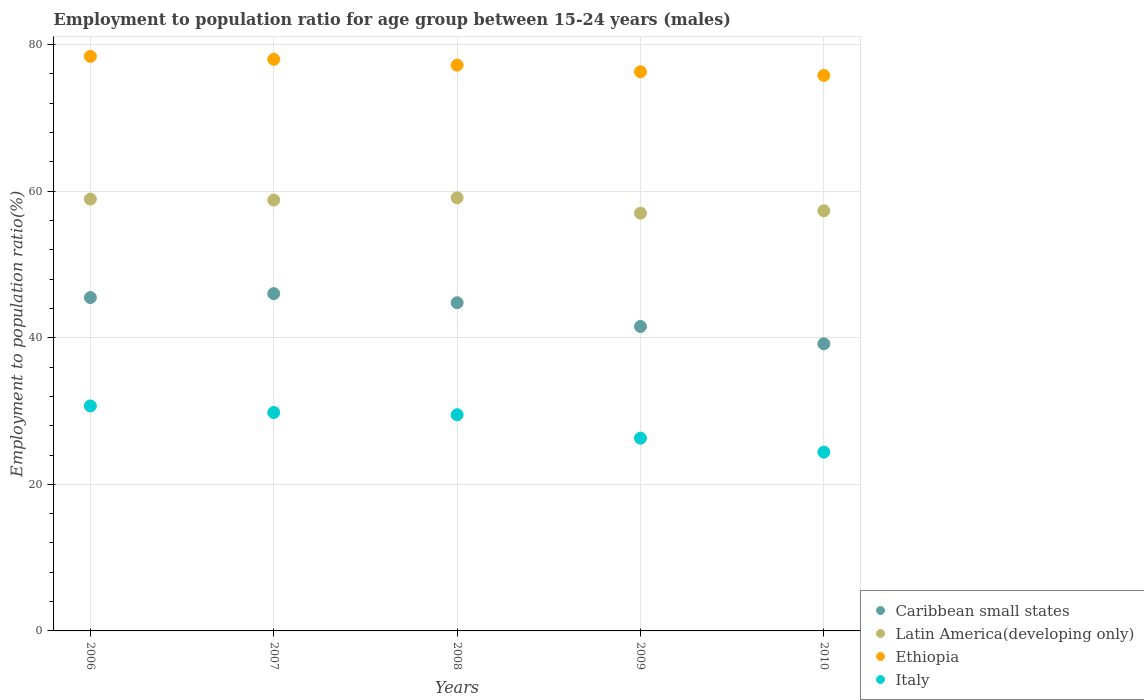How many different coloured dotlines are there?
Offer a very short reply. 4. Is the number of dotlines equal to the number of legend labels?
Make the answer very short. Yes. What is the employment to population ratio in Latin America(developing only) in 2009?
Keep it short and to the point. 57. Across all years, what is the maximum employment to population ratio in Caribbean small states?
Provide a succinct answer. 46.02. Across all years, what is the minimum employment to population ratio in Ethiopia?
Make the answer very short. 75.8. What is the total employment to population ratio in Italy in the graph?
Give a very brief answer. 140.7. What is the difference between the employment to population ratio in Ethiopia in 2007 and that in 2009?
Your answer should be very brief. 1.7. What is the difference between the employment to population ratio in Caribbean small states in 2006 and the employment to population ratio in Latin America(developing only) in 2007?
Make the answer very short. -13.3. What is the average employment to population ratio in Ethiopia per year?
Provide a short and direct response. 77.14. In the year 2008, what is the difference between the employment to population ratio in Latin America(developing only) and employment to population ratio in Caribbean small states?
Keep it short and to the point. 14.31. In how many years, is the employment to population ratio in Italy greater than 40 %?
Give a very brief answer. 0. What is the ratio of the employment to population ratio in Latin America(developing only) in 2007 to that in 2009?
Offer a very short reply. 1.03. Is the employment to population ratio in Italy in 2008 less than that in 2010?
Ensure brevity in your answer.  No. Is the difference between the employment to population ratio in Latin America(developing only) in 2007 and 2010 greater than the difference between the employment to population ratio in Caribbean small states in 2007 and 2010?
Offer a very short reply. No. What is the difference between the highest and the second highest employment to population ratio in Latin America(developing only)?
Offer a terse response. 0.18. What is the difference between the highest and the lowest employment to population ratio in Italy?
Provide a succinct answer. 6.3. Is it the case that in every year, the sum of the employment to population ratio in Latin America(developing only) and employment to population ratio in Caribbean small states  is greater than the sum of employment to population ratio in Ethiopia and employment to population ratio in Italy?
Give a very brief answer. Yes. Is the employment to population ratio in Ethiopia strictly greater than the employment to population ratio in Caribbean small states over the years?
Offer a terse response. Yes. Is the employment to population ratio in Ethiopia strictly less than the employment to population ratio in Latin America(developing only) over the years?
Ensure brevity in your answer.  No. How many dotlines are there?
Your response must be concise. 4. Does the graph contain grids?
Keep it short and to the point. Yes. How many legend labels are there?
Give a very brief answer. 4. What is the title of the graph?
Provide a succinct answer. Employment to population ratio for age group between 15-24 years (males). Does "Costa Rica" appear as one of the legend labels in the graph?
Make the answer very short. No. What is the Employment to population ratio(%) of Caribbean small states in 2006?
Provide a succinct answer. 45.49. What is the Employment to population ratio(%) of Latin America(developing only) in 2006?
Provide a short and direct response. 58.92. What is the Employment to population ratio(%) of Ethiopia in 2006?
Your response must be concise. 78.4. What is the Employment to population ratio(%) of Italy in 2006?
Your response must be concise. 30.7. What is the Employment to population ratio(%) of Caribbean small states in 2007?
Your answer should be compact. 46.02. What is the Employment to population ratio(%) of Latin America(developing only) in 2007?
Offer a very short reply. 58.79. What is the Employment to population ratio(%) of Ethiopia in 2007?
Provide a short and direct response. 78. What is the Employment to population ratio(%) of Italy in 2007?
Give a very brief answer. 29.8. What is the Employment to population ratio(%) of Caribbean small states in 2008?
Offer a terse response. 44.79. What is the Employment to population ratio(%) in Latin America(developing only) in 2008?
Your answer should be compact. 59.1. What is the Employment to population ratio(%) of Ethiopia in 2008?
Keep it short and to the point. 77.2. What is the Employment to population ratio(%) in Italy in 2008?
Provide a short and direct response. 29.5. What is the Employment to population ratio(%) in Caribbean small states in 2009?
Provide a succinct answer. 41.54. What is the Employment to population ratio(%) in Latin America(developing only) in 2009?
Make the answer very short. 57. What is the Employment to population ratio(%) of Ethiopia in 2009?
Offer a very short reply. 76.3. What is the Employment to population ratio(%) of Italy in 2009?
Your answer should be compact. 26.3. What is the Employment to population ratio(%) of Caribbean small states in 2010?
Offer a very short reply. 39.18. What is the Employment to population ratio(%) of Latin America(developing only) in 2010?
Make the answer very short. 57.33. What is the Employment to population ratio(%) in Ethiopia in 2010?
Offer a terse response. 75.8. What is the Employment to population ratio(%) in Italy in 2010?
Offer a very short reply. 24.4. Across all years, what is the maximum Employment to population ratio(%) in Caribbean small states?
Offer a very short reply. 46.02. Across all years, what is the maximum Employment to population ratio(%) in Latin America(developing only)?
Your answer should be very brief. 59.1. Across all years, what is the maximum Employment to population ratio(%) in Ethiopia?
Your response must be concise. 78.4. Across all years, what is the maximum Employment to population ratio(%) of Italy?
Ensure brevity in your answer.  30.7. Across all years, what is the minimum Employment to population ratio(%) in Caribbean small states?
Ensure brevity in your answer.  39.18. Across all years, what is the minimum Employment to population ratio(%) of Latin America(developing only)?
Provide a succinct answer. 57. Across all years, what is the minimum Employment to population ratio(%) of Ethiopia?
Your answer should be compact. 75.8. Across all years, what is the minimum Employment to population ratio(%) in Italy?
Keep it short and to the point. 24.4. What is the total Employment to population ratio(%) of Caribbean small states in the graph?
Your response must be concise. 217.02. What is the total Employment to population ratio(%) in Latin America(developing only) in the graph?
Provide a succinct answer. 291.14. What is the total Employment to population ratio(%) of Ethiopia in the graph?
Keep it short and to the point. 385.7. What is the total Employment to population ratio(%) in Italy in the graph?
Keep it short and to the point. 140.7. What is the difference between the Employment to population ratio(%) in Caribbean small states in 2006 and that in 2007?
Keep it short and to the point. -0.53. What is the difference between the Employment to population ratio(%) in Latin America(developing only) in 2006 and that in 2007?
Your answer should be compact. 0.13. What is the difference between the Employment to population ratio(%) in Ethiopia in 2006 and that in 2007?
Ensure brevity in your answer.  0.4. What is the difference between the Employment to population ratio(%) in Italy in 2006 and that in 2007?
Provide a succinct answer. 0.9. What is the difference between the Employment to population ratio(%) in Caribbean small states in 2006 and that in 2008?
Offer a terse response. 0.7. What is the difference between the Employment to population ratio(%) in Latin America(developing only) in 2006 and that in 2008?
Offer a very short reply. -0.18. What is the difference between the Employment to population ratio(%) of Caribbean small states in 2006 and that in 2009?
Provide a short and direct response. 3.95. What is the difference between the Employment to population ratio(%) of Latin America(developing only) in 2006 and that in 2009?
Offer a terse response. 1.92. What is the difference between the Employment to population ratio(%) of Ethiopia in 2006 and that in 2009?
Offer a very short reply. 2.1. What is the difference between the Employment to population ratio(%) in Caribbean small states in 2006 and that in 2010?
Provide a short and direct response. 6.31. What is the difference between the Employment to population ratio(%) of Latin America(developing only) in 2006 and that in 2010?
Your answer should be compact. 1.59. What is the difference between the Employment to population ratio(%) in Caribbean small states in 2007 and that in 2008?
Provide a short and direct response. 1.24. What is the difference between the Employment to population ratio(%) of Latin America(developing only) in 2007 and that in 2008?
Your answer should be compact. -0.31. What is the difference between the Employment to population ratio(%) of Ethiopia in 2007 and that in 2008?
Give a very brief answer. 0.8. What is the difference between the Employment to population ratio(%) of Caribbean small states in 2007 and that in 2009?
Offer a very short reply. 4.48. What is the difference between the Employment to population ratio(%) in Latin America(developing only) in 2007 and that in 2009?
Make the answer very short. 1.79. What is the difference between the Employment to population ratio(%) in Ethiopia in 2007 and that in 2009?
Make the answer very short. 1.7. What is the difference between the Employment to population ratio(%) of Caribbean small states in 2007 and that in 2010?
Provide a short and direct response. 6.84. What is the difference between the Employment to population ratio(%) in Latin America(developing only) in 2007 and that in 2010?
Your answer should be compact. 1.46. What is the difference between the Employment to population ratio(%) of Caribbean small states in 2008 and that in 2009?
Make the answer very short. 3.24. What is the difference between the Employment to population ratio(%) of Latin America(developing only) in 2008 and that in 2009?
Give a very brief answer. 2.1. What is the difference between the Employment to population ratio(%) of Ethiopia in 2008 and that in 2009?
Provide a short and direct response. 0.9. What is the difference between the Employment to population ratio(%) in Italy in 2008 and that in 2009?
Give a very brief answer. 3.2. What is the difference between the Employment to population ratio(%) of Caribbean small states in 2008 and that in 2010?
Offer a terse response. 5.6. What is the difference between the Employment to population ratio(%) in Latin America(developing only) in 2008 and that in 2010?
Your answer should be very brief. 1.77. What is the difference between the Employment to population ratio(%) in Ethiopia in 2008 and that in 2010?
Your answer should be very brief. 1.4. What is the difference between the Employment to population ratio(%) of Caribbean small states in 2009 and that in 2010?
Provide a short and direct response. 2.36. What is the difference between the Employment to population ratio(%) of Latin America(developing only) in 2009 and that in 2010?
Your response must be concise. -0.33. What is the difference between the Employment to population ratio(%) in Italy in 2009 and that in 2010?
Keep it short and to the point. 1.9. What is the difference between the Employment to population ratio(%) in Caribbean small states in 2006 and the Employment to population ratio(%) in Latin America(developing only) in 2007?
Give a very brief answer. -13.3. What is the difference between the Employment to population ratio(%) in Caribbean small states in 2006 and the Employment to population ratio(%) in Ethiopia in 2007?
Make the answer very short. -32.51. What is the difference between the Employment to population ratio(%) of Caribbean small states in 2006 and the Employment to population ratio(%) of Italy in 2007?
Provide a short and direct response. 15.69. What is the difference between the Employment to population ratio(%) in Latin America(developing only) in 2006 and the Employment to population ratio(%) in Ethiopia in 2007?
Ensure brevity in your answer.  -19.08. What is the difference between the Employment to population ratio(%) of Latin America(developing only) in 2006 and the Employment to population ratio(%) of Italy in 2007?
Your response must be concise. 29.12. What is the difference between the Employment to population ratio(%) in Ethiopia in 2006 and the Employment to population ratio(%) in Italy in 2007?
Give a very brief answer. 48.6. What is the difference between the Employment to population ratio(%) in Caribbean small states in 2006 and the Employment to population ratio(%) in Latin America(developing only) in 2008?
Provide a succinct answer. -13.61. What is the difference between the Employment to population ratio(%) in Caribbean small states in 2006 and the Employment to population ratio(%) in Ethiopia in 2008?
Your response must be concise. -31.71. What is the difference between the Employment to population ratio(%) of Caribbean small states in 2006 and the Employment to population ratio(%) of Italy in 2008?
Your answer should be very brief. 15.99. What is the difference between the Employment to population ratio(%) in Latin America(developing only) in 2006 and the Employment to population ratio(%) in Ethiopia in 2008?
Provide a short and direct response. -18.28. What is the difference between the Employment to population ratio(%) in Latin America(developing only) in 2006 and the Employment to population ratio(%) in Italy in 2008?
Provide a short and direct response. 29.42. What is the difference between the Employment to population ratio(%) of Ethiopia in 2006 and the Employment to population ratio(%) of Italy in 2008?
Your answer should be very brief. 48.9. What is the difference between the Employment to population ratio(%) in Caribbean small states in 2006 and the Employment to population ratio(%) in Latin America(developing only) in 2009?
Provide a short and direct response. -11.51. What is the difference between the Employment to population ratio(%) of Caribbean small states in 2006 and the Employment to population ratio(%) of Ethiopia in 2009?
Provide a short and direct response. -30.81. What is the difference between the Employment to population ratio(%) in Caribbean small states in 2006 and the Employment to population ratio(%) in Italy in 2009?
Your answer should be very brief. 19.19. What is the difference between the Employment to population ratio(%) in Latin America(developing only) in 2006 and the Employment to population ratio(%) in Ethiopia in 2009?
Provide a short and direct response. -17.38. What is the difference between the Employment to population ratio(%) in Latin America(developing only) in 2006 and the Employment to population ratio(%) in Italy in 2009?
Offer a terse response. 32.62. What is the difference between the Employment to population ratio(%) of Ethiopia in 2006 and the Employment to population ratio(%) of Italy in 2009?
Provide a short and direct response. 52.1. What is the difference between the Employment to population ratio(%) in Caribbean small states in 2006 and the Employment to population ratio(%) in Latin America(developing only) in 2010?
Provide a succinct answer. -11.84. What is the difference between the Employment to population ratio(%) in Caribbean small states in 2006 and the Employment to population ratio(%) in Ethiopia in 2010?
Your answer should be very brief. -30.31. What is the difference between the Employment to population ratio(%) of Caribbean small states in 2006 and the Employment to population ratio(%) of Italy in 2010?
Offer a terse response. 21.09. What is the difference between the Employment to population ratio(%) of Latin America(developing only) in 2006 and the Employment to population ratio(%) of Ethiopia in 2010?
Provide a short and direct response. -16.88. What is the difference between the Employment to population ratio(%) of Latin America(developing only) in 2006 and the Employment to population ratio(%) of Italy in 2010?
Your answer should be very brief. 34.52. What is the difference between the Employment to population ratio(%) of Caribbean small states in 2007 and the Employment to population ratio(%) of Latin America(developing only) in 2008?
Keep it short and to the point. -13.08. What is the difference between the Employment to population ratio(%) in Caribbean small states in 2007 and the Employment to population ratio(%) in Ethiopia in 2008?
Your response must be concise. -31.18. What is the difference between the Employment to population ratio(%) in Caribbean small states in 2007 and the Employment to population ratio(%) in Italy in 2008?
Provide a short and direct response. 16.52. What is the difference between the Employment to population ratio(%) of Latin America(developing only) in 2007 and the Employment to population ratio(%) of Ethiopia in 2008?
Keep it short and to the point. -18.41. What is the difference between the Employment to population ratio(%) of Latin America(developing only) in 2007 and the Employment to population ratio(%) of Italy in 2008?
Your answer should be compact. 29.29. What is the difference between the Employment to population ratio(%) of Ethiopia in 2007 and the Employment to population ratio(%) of Italy in 2008?
Provide a succinct answer. 48.5. What is the difference between the Employment to population ratio(%) of Caribbean small states in 2007 and the Employment to population ratio(%) of Latin America(developing only) in 2009?
Ensure brevity in your answer.  -10.98. What is the difference between the Employment to population ratio(%) of Caribbean small states in 2007 and the Employment to population ratio(%) of Ethiopia in 2009?
Your response must be concise. -30.28. What is the difference between the Employment to population ratio(%) of Caribbean small states in 2007 and the Employment to population ratio(%) of Italy in 2009?
Provide a short and direct response. 19.72. What is the difference between the Employment to population ratio(%) in Latin America(developing only) in 2007 and the Employment to population ratio(%) in Ethiopia in 2009?
Offer a very short reply. -17.51. What is the difference between the Employment to population ratio(%) in Latin America(developing only) in 2007 and the Employment to population ratio(%) in Italy in 2009?
Keep it short and to the point. 32.49. What is the difference between the Employment to population ratio(%) of Ethiopia in 2007 and the Employment to population ratio(%) of Italy in 2009?
Make the answer very short. 51.7. What is the difference between the Employment to population ratio(%) of Caribbean small states in 2007 and the Employment to population ratio(%) of Latin America(developing only) in 2010?
Keep it short and to the point. -11.31. What is the difference between the Employment to population ratio(%) in Caribbean small states in 2007 and the Employment to population ratio(%) in Ethiopia in 2010?
Your answer should be compact. -29.78. What is the difference between the Employment to population ratio(%) of Caribbean small states in 2007 and the Employment to population ratio(%) of Italy in 2010?
Your answer should be very brief. 21.62. What is the difference between the Employment to population ratio(%) of Latin America(developing only) in 2007 and the Employment to population ratio(%) of Ethiopia in 2010?
Keep it short and to the point. -17.01. What is the difference between the Employment to population ratio(%) of Latin America(developing only) in 2007 and the Employment to population ratio(%) of Italy in 2010?
Offer a terse response. 34.39. What is the difference between the Employment to population ratio(%) of Ethiopia in 2007 and the Employment to population ratio(%) of Italy in 2010?
Offer a very short reply. 53.6. What is the difference between the Employment to population ratio(%) in Caribbean small states in 2008 and the Employment to population ratio(%) in Latin America(developing only) in 2009?
Offer a terse response. -12.22. What is the difference between the Employment to population ratio(%) in Caribbean small states in 2008 and the Employment to population ratio(%) in Ethiopia in 2009?
Offer a very short reply. -31.51. What is the difference between the Employment to population ratio(%) in Caribbean small states in 2008 and the Employment to population ratio(%) in Italy in 2009?
Your response must be concise. 18.49. What is the difference between the Employment to population ratio(%) in Latin America(developing only) in 2008 and the Employment to population ratio(%) in Ethiopia in 2009?
Your answer should be very brief. -17.2. What is the difference between the Employment to population ratio(%) in Latin America(developing only) in 2008 and the Employment to population ratio(%) in Italy in 2009?
Give a very brief answer. 32.8. What is the difference between the Employment to population ratio(%) of Ethiopia in 2008 and the Employment to population ratio(%) of Italy in 2009?
Offer a terse response. 50.9. What is the difference between the Employment to population ratio(%) of Caribbean small states in 2008 and the Employment to population ratio(%) of Latin America(developing only) in 2010?
Your response must be concise. -12.55. What is the difference between the Employment to population ratio(%) in Caribbean small states in 2008 and the Employment to population ratio(%) in Ethiopia in 2010?
Ensure brevity in your answer.  -31.01. What is the difference between the Employment to population ratio(%) of Caribbean small states in 2008 and the Employment to population ratio(%) of Italy in 2010?
Provide a short and direct response. 20.39. What is the difference between the Employment to population ratio(%) in Latin America(developing only) in 2008 and the Employment to population ratio(%) in Ethiopia in 2010?
Your answer should be very brief. -16.7. What is the difference between the Employment to population ratio(%) in Latin America(developing only) in 2008 and the Employment to population ratio(%) in Italy in 2010?
Your answer should be very brief. 34.7. What is the difference between the Employment to population ratio(%) in Ethiopia in 2008 and the Employment to population ratio(%) in Italy in 2010?
Your answer should be very brief. 52.8. What is the difference between the Employment to population ratio(%) of Caribbean small states in 2009 and the Employment to population ratio(%) of Latin America(developing only) in 2010?
Give a very brief answer. -15.79. What is the difference between the Employment to population ratio(%) in Caribbean small states in 2009 and the Employment to population ratio(%) in Ethiopia in 2010?
Your response must be concise. -34.26. What is the difference between the Employment to population ratio(%) of Caribbean small states in 2009 and the Employment to population ratio(%) of Italy in 2010?
Keep it short and to the point. 17.14. What is the difference between the Employment to population ratio(%) of Latin America(developing only) in 2009 and the Employment to population ratio(%) of Ethiopia in 2010?
Make the answer very short. -18.8. What is the difference between the Employment to population ratio(%) of Latin America(developing only) in 2009 and the Employment to population ratio(%) of Italy in 2010?
Your answer should be very brief. 32.6. What is the difference between the Employment to population ratio(%) in Ethiopia in 2009 and the Employment to population ratio(%) in Italy in 2010?
Make the answer very short. 51.9. What is the average Employment to population ratio(%) in Caribbean small states per year?
Ensure brevity in your answer.  43.4. What is the average Employment to population ratio(%) in Latin America(developing only) per year?
Your answer should be very brief. 58.23. What is the average Employment to population ratio(%) in Ethiopia per year?
Your response must be concise. 77.14. What is the average Employment to population ratio(%) of Italy per year?
Make the answer very short. 28.14. In the year 2006, what is the difference between the Employment to population ratio(%) in Caribbean small states and Employment to population ratio(%) in Latin America(developing only)?
Provide a succinct answer. -13.43. In the year 2006, what is the difference between the Employment to population ratio(%) in Caribbean small states and Employment to population ratio(%) in Ethiopia?
Keep it short and to the point. -32.91. In the year 2006, what is the difference between the Employment to population ratio(%) of Caribbean small states and Employment to population ratio(%) of Italy?
Provide a short and direct response. 14.79. In the year 2006, what is the difference between the Employment to population ratio(%) of Latin America(developing only) and Employment to population ratio(%) of Ethiopia?
Make the answer very short. -19.48. In the year 2006, what is the difference between the Employment to population ratio(%) of Latin America(developing only) and Employment to population ratio(%) of Italy?
Make the answer very short. 28.22. In the year 2006, what is the difference between the Employment to population ratio(%) of Ethiopia and Employment to population ratio(%) of Italy?
Provide a short and direct response. 47.7. In the year 2007, what is the difference between the Employment to population ratio(%) of Caribbean small states and Employment to population ratio(%) of Latin America(developing only)?
Give a very brief answer. -12.77. In the year 2007, what is the difference between the Employment to population ratio(%) of Caribbean small states and Employment to population ratio(%) of Ethiopia?
Your response must be concise. -31.98. In the year 2007, what is the difference between the Employment to population ratio(%) of Caribbean small states and Employment to population ratio(%) of Italy?
Provide a short and direct response. 16.22. In the year 2007, what is the difference between the Employment to population ratio(%) in Latin America(developing only) and Employment to population ratio(%) in Ethiopia?
Your answer should be compact. -19.21. In the year 2007, what is the difference between the Employment to population ratio(%) in Latin America(developing only) and Employment to population ratio(%) in Italy?
Your answer should be very brief. 28.99. In the year 2007, what is the difference between the Employment to population ratio(%) in Ethiopia and Employment to population ratio(%) in Italy?
Give a very brief answer. 48.2. In the year 2008, what is the difference between the Employment to population ratio(%) of Caribbean small states and Employment to population ratio(%) of Latin America(developing only)?
Your response must be concise. -14.31. In the year 2008, what is the difference between the Employment to population ratio(%) in Caribbean small states and Employment to population ratio(%) in Ethiopia?
Provide a short and direct response. -32.41. In the year 2008, what is the difference between the Employment to population ratio(%) in Caribbean small states and Employment to population ratio(%) in Italy?
Ensure brevity in your answer.  15.29. In the year 2008, what is the difference between the Employment to population ratio(%) of Latin America(developing only) and Employment to population ratio(%) of Ethiopia?
Provide a short and direct response. -18.1. In the year 2008, what is the difference between the Employment to population ratio(%) of Latin America(developing only) and Employment to population ratio(%) of Italy?
Ensure brevity in your answer.  29.6. In the year 2008, what is the difference between the Employment to population ratio(%) of Ethiopia and Employment to population ratio(%) of Italy?
Your response must be concise. 47.7. In the year 2009, what is the difference between the Employment to population ratio(%) of Caribbean small states and Employment to population ratio(%) of Latin America(developing only)?
Provide a short and direct response. -15.46. In the year 2009, what is the difference between the Employment to population ratio(%) of Caribbean small states and Employment to population ratio(%) of Ethiopia?
Keep it short and to the point. -34.76. In the year 2009, what is the difference between the Employment to population ratio(%) of Caribbean small states and Employment to population ratio(%) of Italy?
Ensure brevity in your answer.  15.24. In the year 2009, what is the difference between the Employment to population ratio(%) in Latin America(developing only) and Employment to population ratio(%) in Ethiopia?
Ensure brevity in your answer.  -19.3. In the year 2009, what is the difference between the Employment to population ratio(%) in Latin America(developing only) and Employment to population ratio(%) in Italy?
Keep it short and to the point. 30.7. In the year 2010, what is the difference between the Employment to population ratio(%) of Caribbean small states and Employment to population ratio(%) of Latin America(developing only)?
Your response must be concise. -18.15. In the year 2010, what is the difference between the Employment to population ratio(%) in Caribbean small states and Employment to population ratio(%) in Ethiopia?
Offer a very short reply. -36.62. In the year 2010, what is the difference between the Employment to population ratio(%) in Caribbean small states and Employment to population ratio(%) in Italy?
Your answer should be compact. 14.78. In the year 2010, what is the difference between the Employment to population ratio(%) of Latin America(developing only) and Employment to population ratio(%) of Ethiopia?
Your response must be concise. -18.47. In the year 2010, what is the difference between the Employment to population ratio(%) in Latin America(developing only) and Employment to population ratio(%) in Italy?
Offer a terse response. 32.93. In the year 2010, what is the difference between the Employment to population ratio(%) of Ethiopia and Employment to population ratio(%) of Italy?
Your response must be concise. 51.4. What is the ratio of the Employment to population ratio(%) in Caribbean small states in 2006 to that in 2007?
Offer a very short reply. 0.99. What is the ratio of the Employment to population ratio(%) in Italy in 2006 to that in 2007?
Make the answer very short. 1.03. What is the ratio of the Employment to population ratio(%) of Caribbean small states in 2006 to that in 2008?
Your answer should be very brief. 1.02. What is the ratio of the Employment to population ratio(%) in Latin America(developing only) in 2006 to that in 2008?
Make the answer very short. 1. What is the ratio of the Employment to population ratio(%) in Ethiopia in 2006 to that in 2008?
Offer a very short reply. 1.02. What is the ratio of the Employment to population ratio(%) of Italy in 2006 to that in 2008?
Provide a short and direct response. 1.04. What is the ratio of the Employment to population ratio(%) in Caribbean small states in 2006 to that in 2009?
Ensure brevity in your answer.  1.09. What is the ratio of the Employment to population ratio(%) of Latin America(developing only) in 2006 to that in 2009?
Your answer should be very brief. 1.03. What is the ratio of the Employment to population ratio(%) in Ethiopia in 2006 to that in 2009?
Your answer should be very brief. 1.03. What is the ratio of the Employment to population ratio(%) of Italy in 2006 to that in 2009?
Offer a very short reply. 1.17. What is the ratio of the Employment to population ratio(%) of Caribbean small states in 2006 to that in 2010?
Offer a terse response. 1.16. What is the ratio of the Employment to population ratio(%) of Latin America(developing only) in 2006 to that in 2010?
Offer a terse response. 1.03. What is the ratio of the Employment to population ratio(%) in Ethiopia in 2006 to that in 2010?
Your answer should be very brief. 1.03. What is the ratio of the Employment to population ratio(%) in Italy in 2006 to that in 2010?
Offer a terse response. 1.26. What is the ratio of the Employment to population ratio(%) in Caribbean small states in 2007 to that in 2008?
Make the answer very short. 1.03. What is the ratio of the Employment to population ratio(%) in Latin America(developing only) in 2007 to that in 2008?
Your response must be concise. 0.99. What is the ratio of the Employment to population ratio(%) in Ethiopia in 2007 to that in 2008?
Offer a terse response. 1.01. What is the ratio of the Employment to population ratio(%) of Italy in 2007 to that in 2008?
Make the answer very short. 1.01. What is the ratio of the Employment to population ratio(%) of Caribbean small states in 2007 to that in 2009?
Provide a short and direct response. 1.11. What is the ratio of the Employment to population ratio(%) in Latin America(developing only) in 2007 to that in 2009?
Your answer should be very brief. 1.03. What is the ratio of the Employment to population ratio(%) of Ethiopia in 2007 to that in 2009?
Make the answer very short. 1.02. What is the ratio of the Employment to population ratio(%) in Italy in 2007 to that in 2009?
Give a very brief answer. 1.13. What is the ratio of the Employment to population ratio(%) of Caribbean small states in 2007 to that in 2010?
Make the answer very short. 1.17. What is the ratio of the Employment to population ratio(%) of Latin America(developing only) in 2007 to that in 2010?
Keep it short and to the point. 1.03. What is the ratio of the Employment to population ratio(%) in Italy in 2007 to that in 2010?
Your response must be concise. 1.22. What is the ratio of the Employment to population ratio(%) of Caribbean small states in 2008 to that in 2009?
Make the answer very short. 1.08. What is the ratio of the Employment to population ratio(%) in Latin America(developing only) in 2008 to that in 2009?
Provide a short and direct response. 1.04. What is the ratio of the Employment to population ratio(%) in Ethiopia in 2008 to that in 2009?
Your response must be concise. 1.01. What is the ratio of the Employment to population ratio(%) in Italy in 2008 to that in 2009?
Make the answer very short. 1.12. What is the ratio of the Employment to population ratio(%) in Caribbean small states in 2008 to that in 2010?
Provide a short and direct response. 1.14. What is the ratio of the Employment to population ratio(%) of Latin America(developing only) in 2008 to that in 2010?
Provide a short and direct response. 1.03. What is the ratio of the Employment to population ratio(%) of Ethiopia in 2008 to that in 2010?
Your answer should be compact. 1.02. What is the ratio of the Employment to population ratio(%) of Italy in 2008 to that in 2010?
Make the answer very short. 1.21. What is the ratio of the Employment to population ratio(%) of Caribbean small states in 2009 to that in 2010?
Your answer should be very brief. 1.06. What is the ratio of the Employment to population ratio(%) in Latin America(developing only) in 2009 to that in 2010?
Your answer should be very brief. 0.99. What is the ratio of the Employment to population ratio(%) in Ethiopia in 2009 to that in 2010?
Your answer should be compact. 1.01. What is the ratio of the Employment to population ratio(%) in Italy in 2009 to that in 2010?
Give a very brief answer. 1.08. What is the difference between the highest and the second highest Employment to population ratio(%) in Caribbean small states?
Make the answer very short. 0.53. What is the difference between the highest and the second highest Employment to population ratio(%) of Latin America(developing only)?
Provide a short and direct response. 0.18. What is the difference between the highest and the second highest Employment to population ratio(%) of Italy?
Offer a very short reply. 0.9. What is the difference between the highest and the lowest Employment to population ratio(%) in Caribbean small states?
Offer a very short reply. 6.84. What is the difference between the highest and the lowest Employment to population ratio(%) in Latin America(developing only)?
Provide a succinct answer. 2.1. What is the difference between the highest and the lowest Employment to population ratio(%) in Ethiopia?
Offer a very short reply. 2.6. 